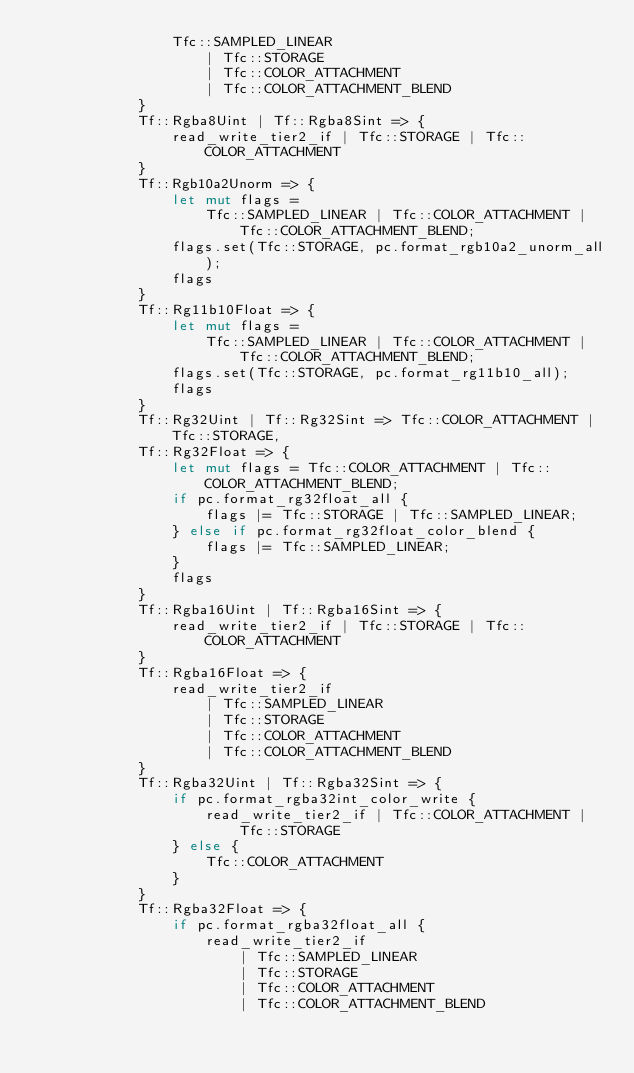<code> <loc_0><loc_0><loc_500><loc_500><_Rust_>                Tfc::SAMPLED_LINEAR
                    | Tfc::STORAGE
                    | Tfc::COLOR_ATTACHMENT
                    | Tfc::COLOR_ATTACHMENT_BLEND
            }
            Tf::Rgba8Uint | Tf::Rgba8Sint => {
                read_write_tier2_if | Tfc::STORAGE | Tfc::COLOR_ATTACHMENT
            }
            Tf::Rgb10a2Unorm => {
                let mut flags =
                    Tfc::SAMPLED_LINEAR | Tfc::COLOR_ATTACHMENT | Tfc::COLOR_ATTACHMENT_BLEND;
                flags.set(Tfc::STORAGE, pc.format_rgb10a2_unorm_all);
                flags
            }
            Tf::Rg11b10Float => {
                let mut flags =
                    Tfc::SAMPLED_LINEAR | Tfc::COLOR_ATTACHMENT | Tfc::COLOR_ATTACHMENT_BLEND;
                flags.set(Tfc::STORAGE, pc.format_rg11b10_all);
                flags
            }
            Tf::Rg32Uint | Tf::Rg32Sint => Tfc::COLOR_ATTACHMENT | Tfc::STORAGE,
            Tf::Rg32Float => {
                let mut flags = Tfc::COLOR_ATTACHMENT | Tfc::COLOR_ATTACHMENT_BLEND;
                if pc.format_rg32float_all {
                    flags |= Tfc::STORAGE | Tfc::SAMPLED_LINEAR;
                } else if pc.format_rg32float_color_blend {
                    flags |= Tfc::SAMPLED_LINEAR;
                }
                flags
            }
            Tf::Rgba16Uint | Tf::Rgba16Sint => {
                read_write_tier2_if | Tfc::STORAGE | Tfc::COLOR_ATTACHMENT
            }
            Tf::Rgba16Float => {
                read_write_tier2_if
                    | Tfc::SAMPLED_LINEAR
                    | Tfc::STORAGE
                    | Tfc::COLOR_ATTACHMENT
                    | Tfc::COLOR_ATTACHMENT_BLEND
            }
            Tf::Rgba32Uint | Tf::Rgba32Sint => {
                if pc.format_rgba32int_color_write {
                    read_write_tier2_if | Tfc::COLOR_ATTACHMENT | Tfc::STORAGE
                } else {
                    Tfc::COLOR_ATTACHMENT
                }
            }
            Tf::Rgba32Float => {
                if pc.format_rgba32float_all {
                    read_write_tier2_if
                        | Tfc::SAMPLED_LINEAR
                        | Tfc::STORAGE
                        | Tfc::COLOR_ATTACHMENT
                        | Tfc::COLOR_ATTACHMENT_BLEND</code> 